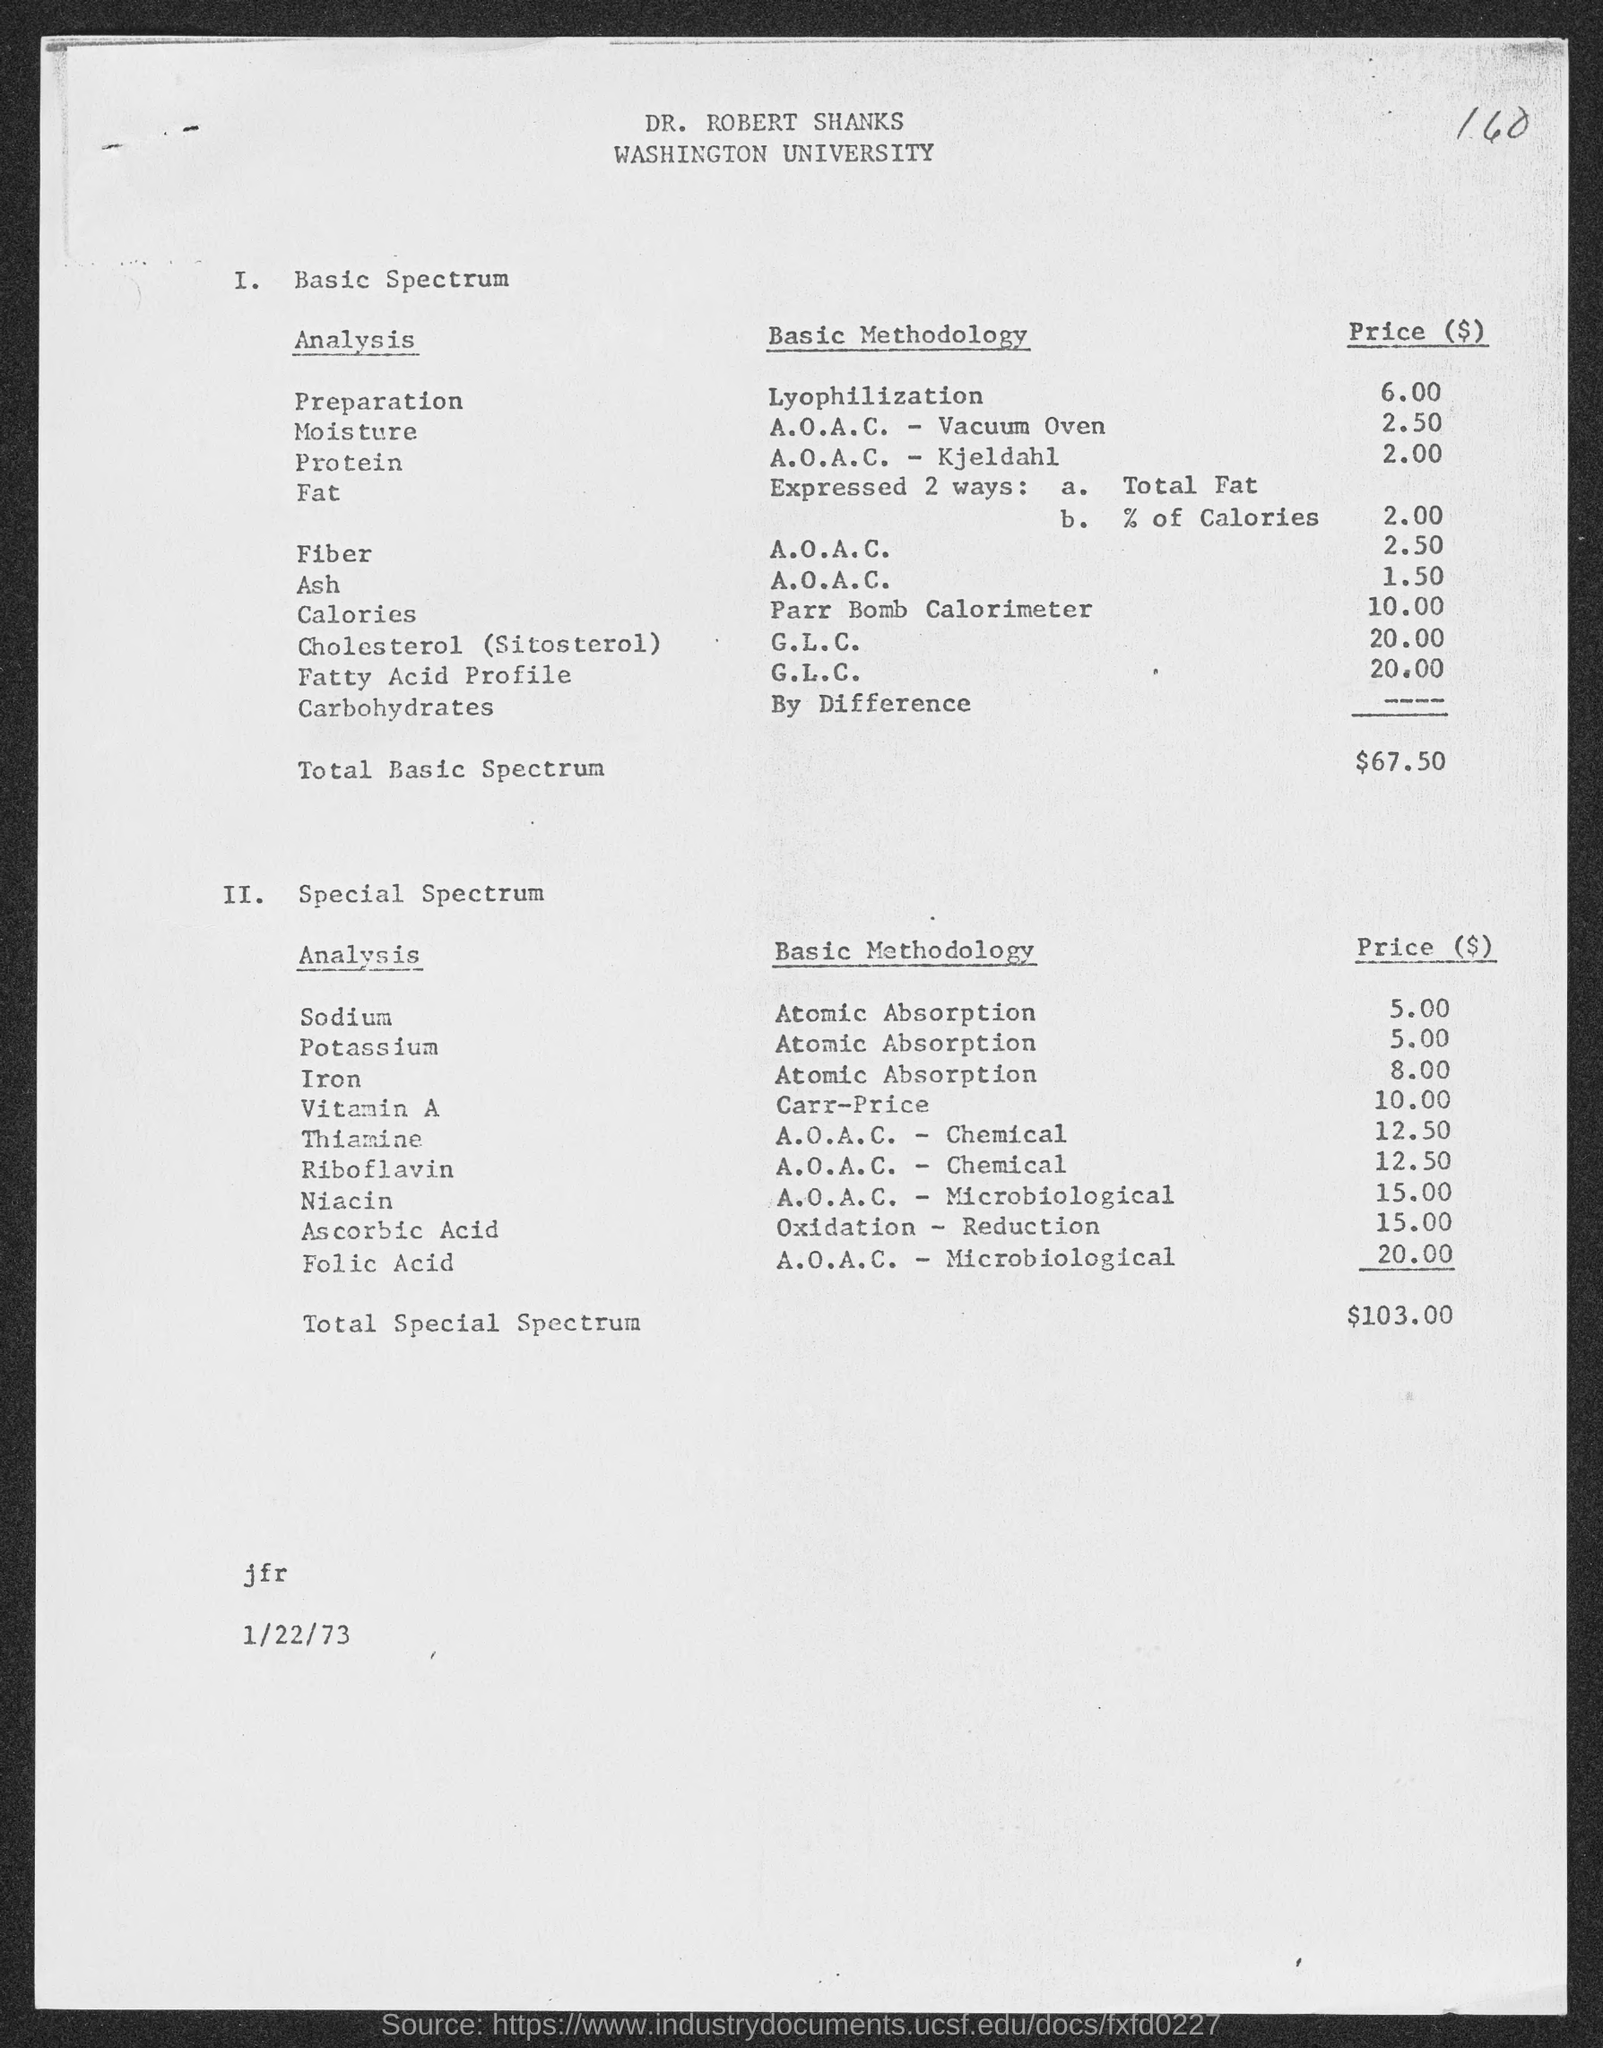Give some essential details in this illustration. The amount of total basic spectrum mentioned in the given page is $67.50. The name of the university mentioned in the given page is Washington University. The cost of niacin analysis using the A.O.A.C.-Microbiological methodology is $15.00. The cost of potassium analysis using atomic absorption methodology is 5.00... The price of vitamin A analysis using the Carr methodology is 10.00. 